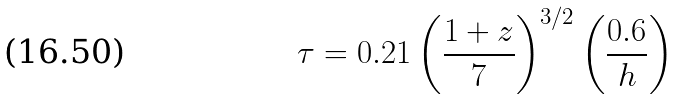<formula> <loc_0><loc_0><loc_500><loc_500>\tau = 0 . 2 1 \left ( \frac { 1 + z } { 7 } \right ) ^ { 3 / 2 } \left ( \frac { 0 . 6 } { h } \right )</formula> 